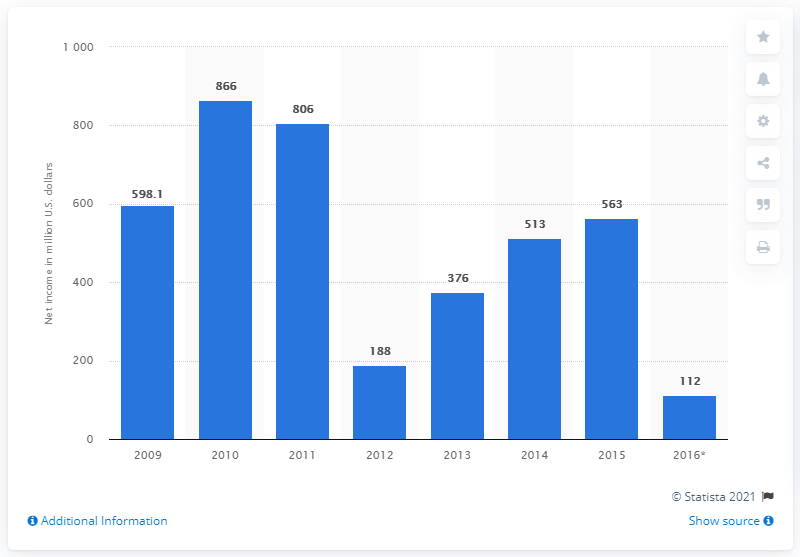Draw attention to some important aspects in this diagram. In the year 2009, Dow Corning Corp. reported its first net income. Dow Corning Corporation reported a net income of $563 million in 2015. 